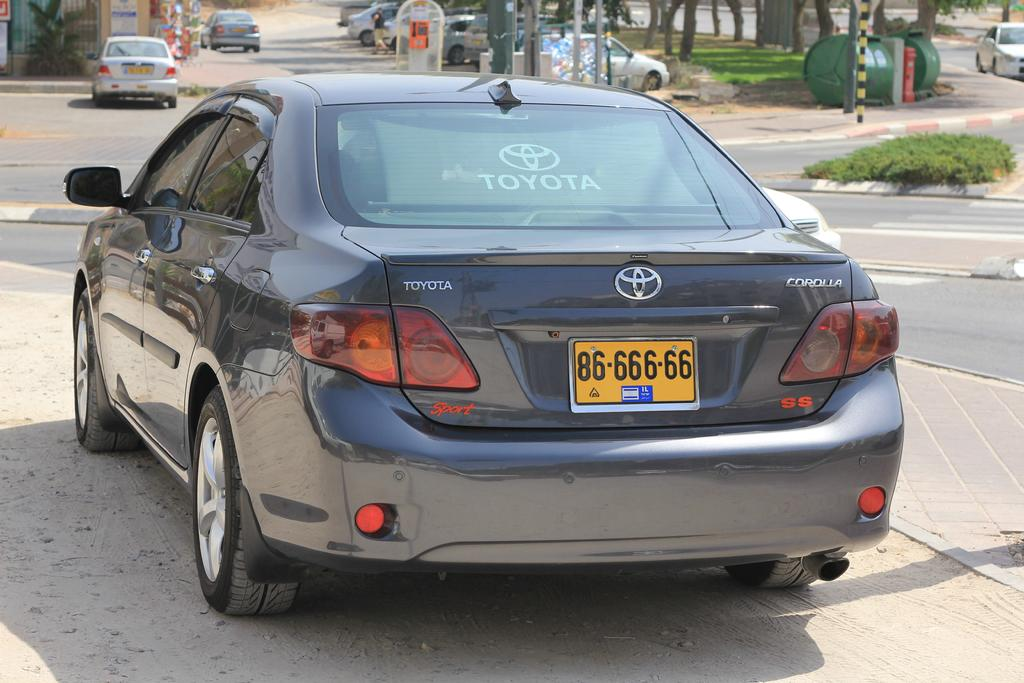<image>
Share a concise interpretation of the image provided. A black Toyota Corolla with orange license plate. 